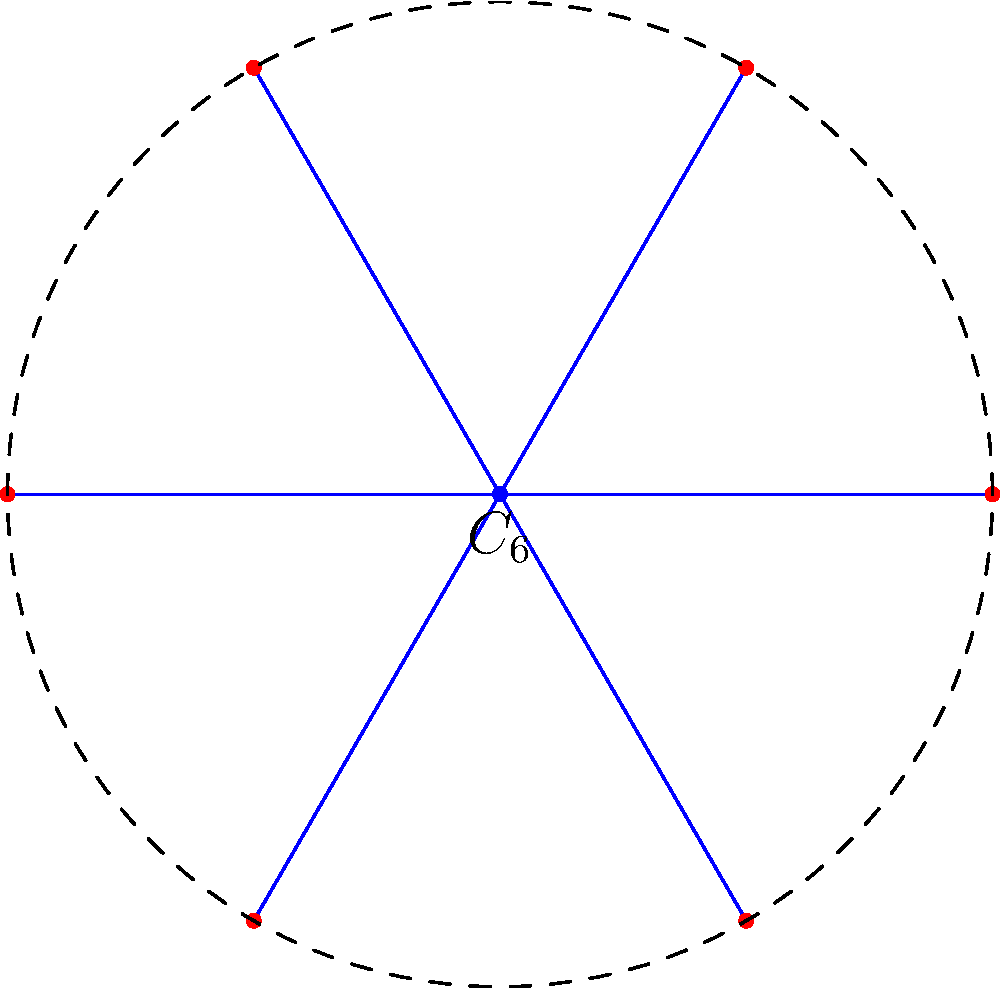In your firework pattern design, you've created a symmetrical arrangement of 6 spark points around a central explosion point, as shown in the diagram. Which symmetry group does this pattern represent, and what is the order of this group? To determine the symmetry group and its order, let's analyze the pattern step-by-step:

1. The pattern shows 6 equally spaced points around a central point, forming a regular hexagon.

2. This arrangement has rotational symmetry:
   - It can be rotated by multiples of 60° (360°/6) and remain unchanged.
   - There are 6 possible rotations: 0°, 60°, 120°, 180°, 240°, and 300°.

3. The pattern also has reflection symmetry:
   - There are 6 lines of reflection (3 through opposite vertices and 3 through the midpoints of opposite sides).

4. The combination of these rotations and reflections forms the dihedral group $D_6$.

5. The order of the group is calculated as follows:
   - Number of rotations: 6
   - Number of reflections: 6
   - Total number of symmetries: 6 + 6 = 12

Therefore, the symmetry group is $D_6$ (dihedral group of order 12), and its order is 12.
Answer: $D_6$, order 12 